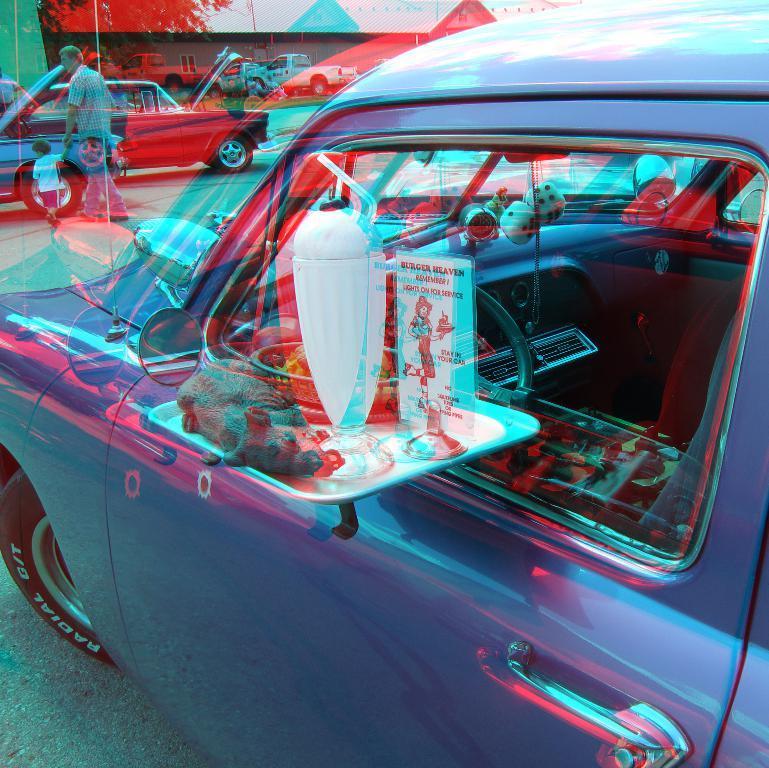Can you describe this image briefly? In this image we can see the side view of a car, in front of the car there is a man and a child walking on the road, in front of the man there are cars and houses. 